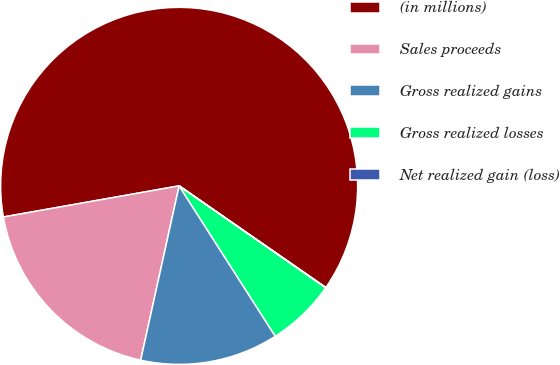Convert chart to OTSL. <chart><loc_0><loc_0><loc_500><loc_500><pie_chart><fcel>(in millions)<fcel>Sales proceeds<fcel>Gross realized gains<fcel>Gross realized losses<fcel>Net realized gain (loss)<nl><fcel>62.43%<fcel>18.75%<fcel>12.51%<fcel>6.27%<fcel>0.03%<nl></chart> 